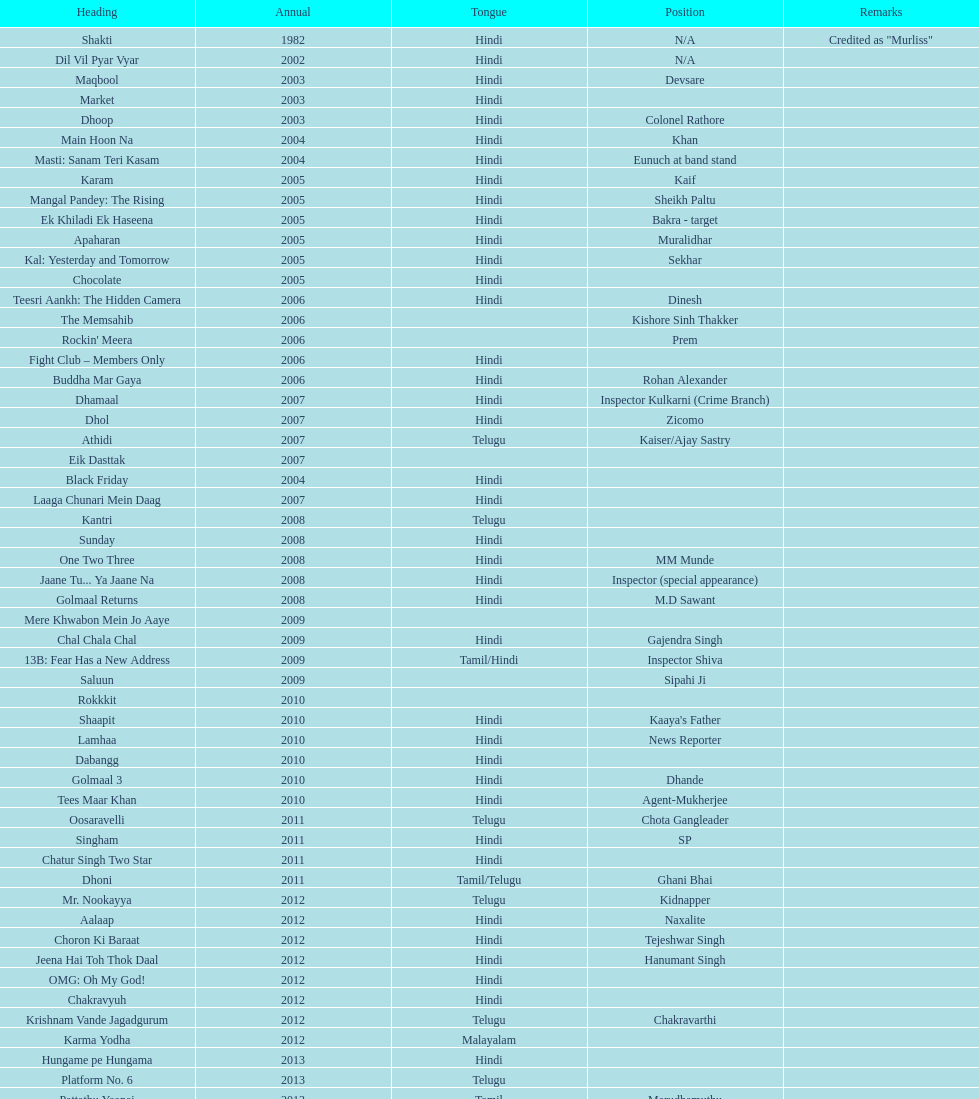Does maqbool have longer notes than shakti? No. Could you help me parse every detail presented in this table? {'header': ['Heading', 'Annual', 'Tongue', 'Position', 'Remarks'], 'rows': [['Shakti', '1982', 'Hindi', 'N/A', 'Credited as "Murliss"'], ['Dil Vil Pyar Vyar', '2002', 'Hindi', 'N/A', ''], ['Maqbool', '2003', 'Hindi', 'Devsare', ''], ['Market', '2003', 'Hindi', '', ''], ['Dhoop', '2003', 'Hindi', 'Colonel Rathore', ''], ['Main Hoon Na', '2004', 'Hindi', 'Khan', ''], ['Masti: Sanam Teri Kasam', '2004', 'Hindi', 'Eunuch at band stand', ''], ['Karam', '2005', 'Hindi', 'Kaif', ''], ['Mangal Pandey: The Rising', '2005', 'Hindi', 'Sheikh Paltu', ''], ['Ek Khiladi Ek Haseena', '2005', 'Hindi', 'Bakra - target', ''], ['Apaharan', '2005', 'Hindi', 'Muralidhar', ''], ['Kal: Yesterday and Tomorrow', '2005', 'Hindi', 'Sekhar', ''], ['Chocolate', '2005', 'Hindi', '', ''], ['Teesri Aankh: The Hidden Camera', '2006', 'Hindi', 'Dinesh', ''], ['The Memsahib', '2006', '', 'Kishore Sinh Thakker', ''], ["Rockin' Meera", '2006', '', 'Prem', ''], ['Fight Club – Members Only', '2006', 'Hindi', '', ''], ['Buddha Mar Gaya', '2006', 'Hindi', 'Rohan Alexander', ''], ['Dhamaal', '2007', 'Hindi', 'Inspector Kulkarni (Crime Branch)', ''], ['Dhol', '2007', 'Hindi', 'Zicomo', ''], ['Athidi', '2007', 'Telugu', 'Kaiser/Ajay Sastry', ''], ['Eik Dasttak', '2007', '', '', ''], ['Black Friday', '2004', 'Hindi', '', ''], ['Laaga Chunari Mein Daag', '2007', 'Hindi', '', ''], ['Kantri', '2008', 'Telugu', '', ''], ['Sunday', '2008', 'Hindi', '', ''], ['One Two Three', '2008', 'Hindi', 'MM Munde', ''], ['Jaane Tu... Ya Jaane Na', '2008', 'Hindi', 'Inspector (special appearance)', ''], ['Golmaal Returns', '2008', 'Hindi', 'M.D Sawant', ''], ['Mere Khwabon Mein Jo Aaye', '2009', '', '', ''], ['Chal Chala Chal', '2009', 'Hindi', 'Gajendra Singh', ''], ['13B: Fear Has a New Address', '2009', 'Tamil/Hindi', 'Inspector Shiva', ''], ['Saluun', '2009', '', 'Sipahi Ji', ''], ['Rokkkit', '2010', '', '', ''], ['Shaapit', '2010', 'Hindi', "Kaaya's Father", ''], ['Lamhaa', '2010', 'Hindi', 'News Reporter', ''], ['Dabangg', '2010', 'Hindi', '', ''], ['Golmaal 3', '2010', 'Hindi', 'Dhande', ''], ['Tees Maar Khan', '2010', 'Hindi', 'Agent-Mukherjee', ''], ['Oosaravelli', '2011', 'Telugu', 'Chota Gangleader', ''], ['Singham', '2011', 'Hindi', 'SP', ''], ['Chatur Singh Two Star', '2011', 'Hindi', '', ''], ['Dhoni', '2011', 'Tamil/Telugu', 'Ghani Bhai', ''], ['Mr. Nookayya', '2012', 'Telugu', 'Kidnapper', ''], ['Aalaap', '2012', 'Hindi', 'Naxalite', ''], ['Choron Ki Baraat', '2012', 'Hindi', 'Tejeshwar Singh', ''], ['Jeena Hai Toh Thok Daal', '2012', 'Hindi', 'Hanumant Singh', ''], ['OMG: Oh My God!', '2012', 'Hindi', '', ''], ['Chakravyuh', '2012', 'Hindi', '', ''], ['Krishnam Vande Jagadgurum', '2012', 'Telugu', 'Chakravarthi', ''], ['Karma Yodha', '2012', 'Malayalam', '', ''], ['Hungame pe Hungama', '2013', 'Hindi', '', ''], ['Platform No. 6', '2013', 'Telugu', '', ''], ['Pattathu Yaanai', '2013', 'Tamil', 'Marudhamuthu', ''], ['Zindagi 50-50', '2013', 'Hindi', '', ''], ['Yevadu', '2013', 'Telugu', 'Durani', ''], ['Karmachari', '2013', 'Telugu', '', '']]} 